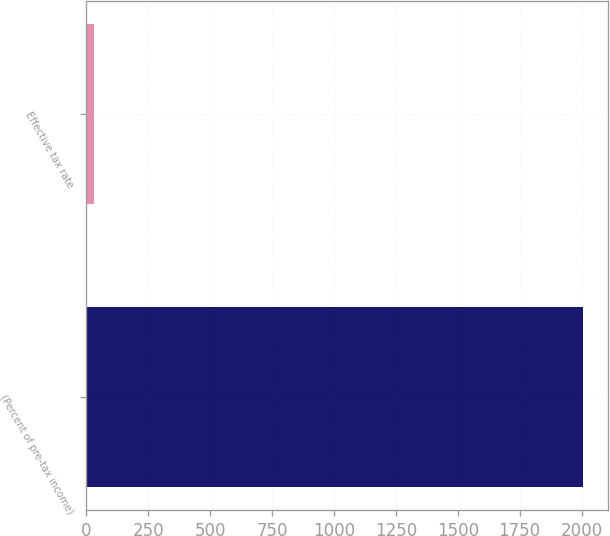<chart> <loc_0><loc_0><loc_500><loc_500><bar_chart><fcel>(Percent of pre-tax income)<fcel>Effective tax rate<nl><fcel>2006<fcel>30.6<nl></chart> 